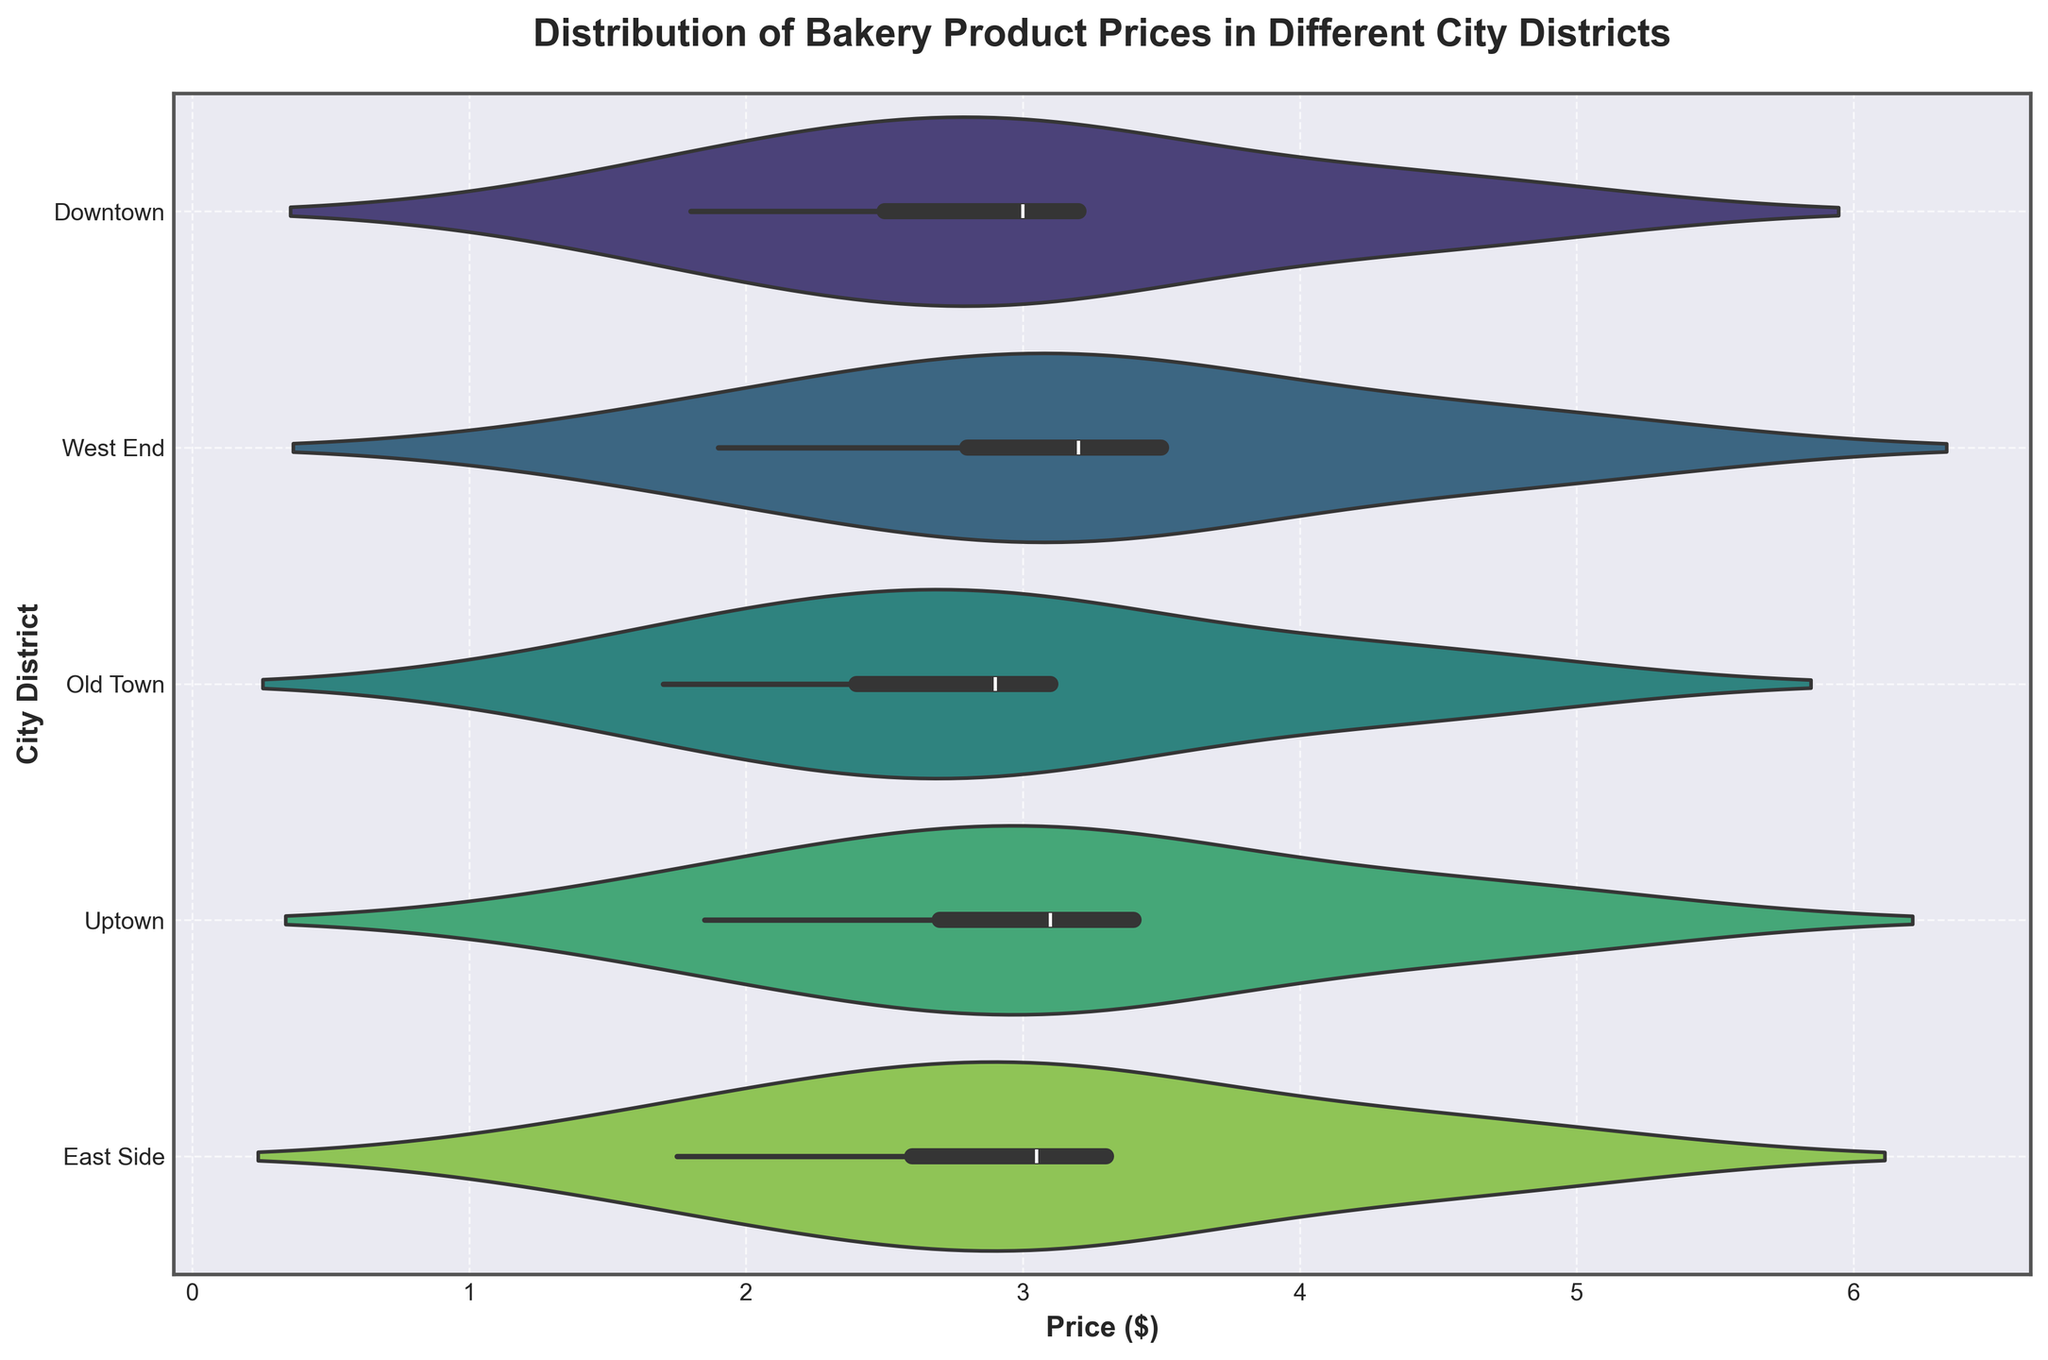Which city district has the highest median bakery product price? To find the highest median price, visually locate the center line of each violin plot, which represents the median. Compare these medians across all districts and identify the one with the highest line.
Answer: West End What is the title of the figure? Look at the text placed prominently at the top of the figure.
Answer: Distribution of Bakery Product Prices in Different City Districts Which city district shows the widest price range? Examine the width of the individual violin plots; the widest range will appear as a spread out or elongated shape horizontally.
Answer: West End How does the median bakery product price in Downtown compare to Old Town? Find and compare the center lines (medians) of the violin plots for Downtown and Old Town to see which is higher.
Answer: Downtown is higher What is the range of bakery product prices in Uptown? Observe the horizontal extent of the violin plot for Uptown to determine the minimum and maximum prices. Subtract the minimum price from the maximum price.
Answer: 4.7 - 1.85 = 2.85 Which district has the most symmetrical price distribution for bakery products? Look at the shape of each violin plot; the most symmetrical distribution has evenly spread density around the median line.
Answer: Uptown Is the modal price of bakery products in East Side higher or lower than in Downtown? Identify the peak areas of the violin plots, which indicate the mode, for both East Side and Downtown. Compare their heights.
Answer: Higher in Downtown Which city district has the least variability in bakery product prices? Identify the violin plot with the narrowest spread, which indicates the least variability in prices.
Answer: Old Town How many city districts are displayed in the figure? Count the distinct labeled horizontal sections in the violin chart.
Answer: 5 Comparing East Side and West End, which has more spread in their bakery product prices? Compare the horizontal spread of the violin plots for East Side and West End. The plot with the wider spread indicates more variability.
Answer: West End 